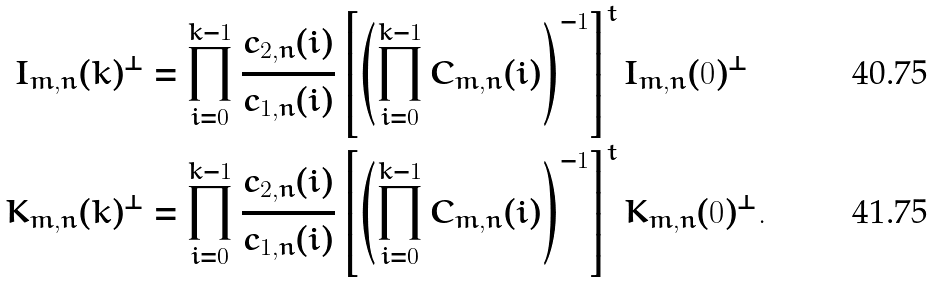Convert formula to latex. <formula><loc_0><loc_0><loc_500><loc_500>I _ { m , n } ( k ) ^ { \perp } & = \prod _ { i = 0 } ^ { k - 1 } \frac { c _ { 2 , n } ( i ) } { c _ { 1 , n } ( i ) } \left [ \left ( \prod _ { i = 0 } ^ { k - 1 } C _ { m , n } ( i ) \right ) ^ { - 1 } \right ] ^ { t } I _ { m , n } ( 0 ) ^ { \perp } \\ K _ { m , n } ( k ) ^ { \perp } & = \prod _ { i = 0 } ^ { k - 1 } \frac { c _ { 2 , n } ( i ) } { c _ { 1 , n } ( i ) } \left [ \left ( \prod _ { i = 0 } ^ { k - 1 } C _ { m , n } ( i ) \right ) ^ { - 1 } \right ] ^ { t } K _ { m , n } ( 0 ) ^ { \perp } .</formula> 